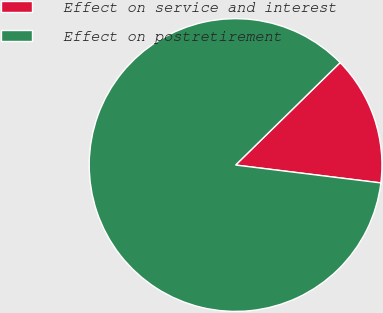<chart> <loc_0><loc_0><loc_500><loc_500><pie_chart><fcel>Effect on service and interest<fcel>Effect on postretirement<nl><fcel>14.29%<fcel>85.71%<nl></chart> 